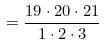Convert formula to latex. <formula><loc_0><loc_0><loc_500><loc_500>= \frac { 1 9 \cdot 2 0 \cdot 2 1 } { 1 \cdot 2 \cdot 3 }</formula> 